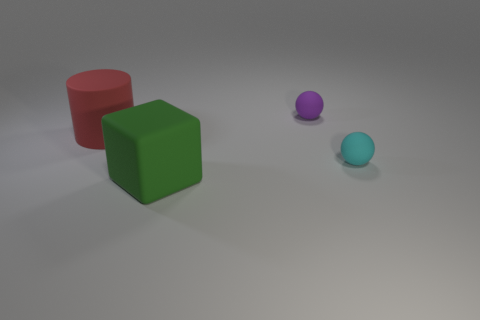Are there any green rubber blocks of the same size as the red matte cylinder?
Make the answer very short. Yes. There is a block that is the same size as the red cylinder; what material is it?
Keep it short and to the point. Rubber. What is the size of the rubber ball that is to the left of the small object to the right of the small purple matte sphere?
Provide a succinct answer. Small. Does the object to the right of the purple ball have the same size as the purple object?
Ensure brevity in your answer.  Yes. Is the number of purple matte balls that are behind the purple matte ball greater than the number of red matte things to the right of the cyan matte ball?
Give a very brief answer. No. The matte object that is left of the purple rubber ball and to the right of the large red cylinder has what shape?
Your answer should be compact. Cube. There is a large thing that is behind the green rubber block; what shape is it?
Provide a short and direct response. Cylinder. There is a matte ball behind the small matte ball that is in front of the tiny ball that is on the left side of the small cyan object; what size is it?
Ensure brevity in your answer.  Small. Is the shape of the small purple thing the same as the cyan thing?
Offer a very short reply. Yes. There is a rubber thing that is both in front of the matte cylinder and left of the tiny cyan matte object; what is its size?
Your answer should be compact. Large. 